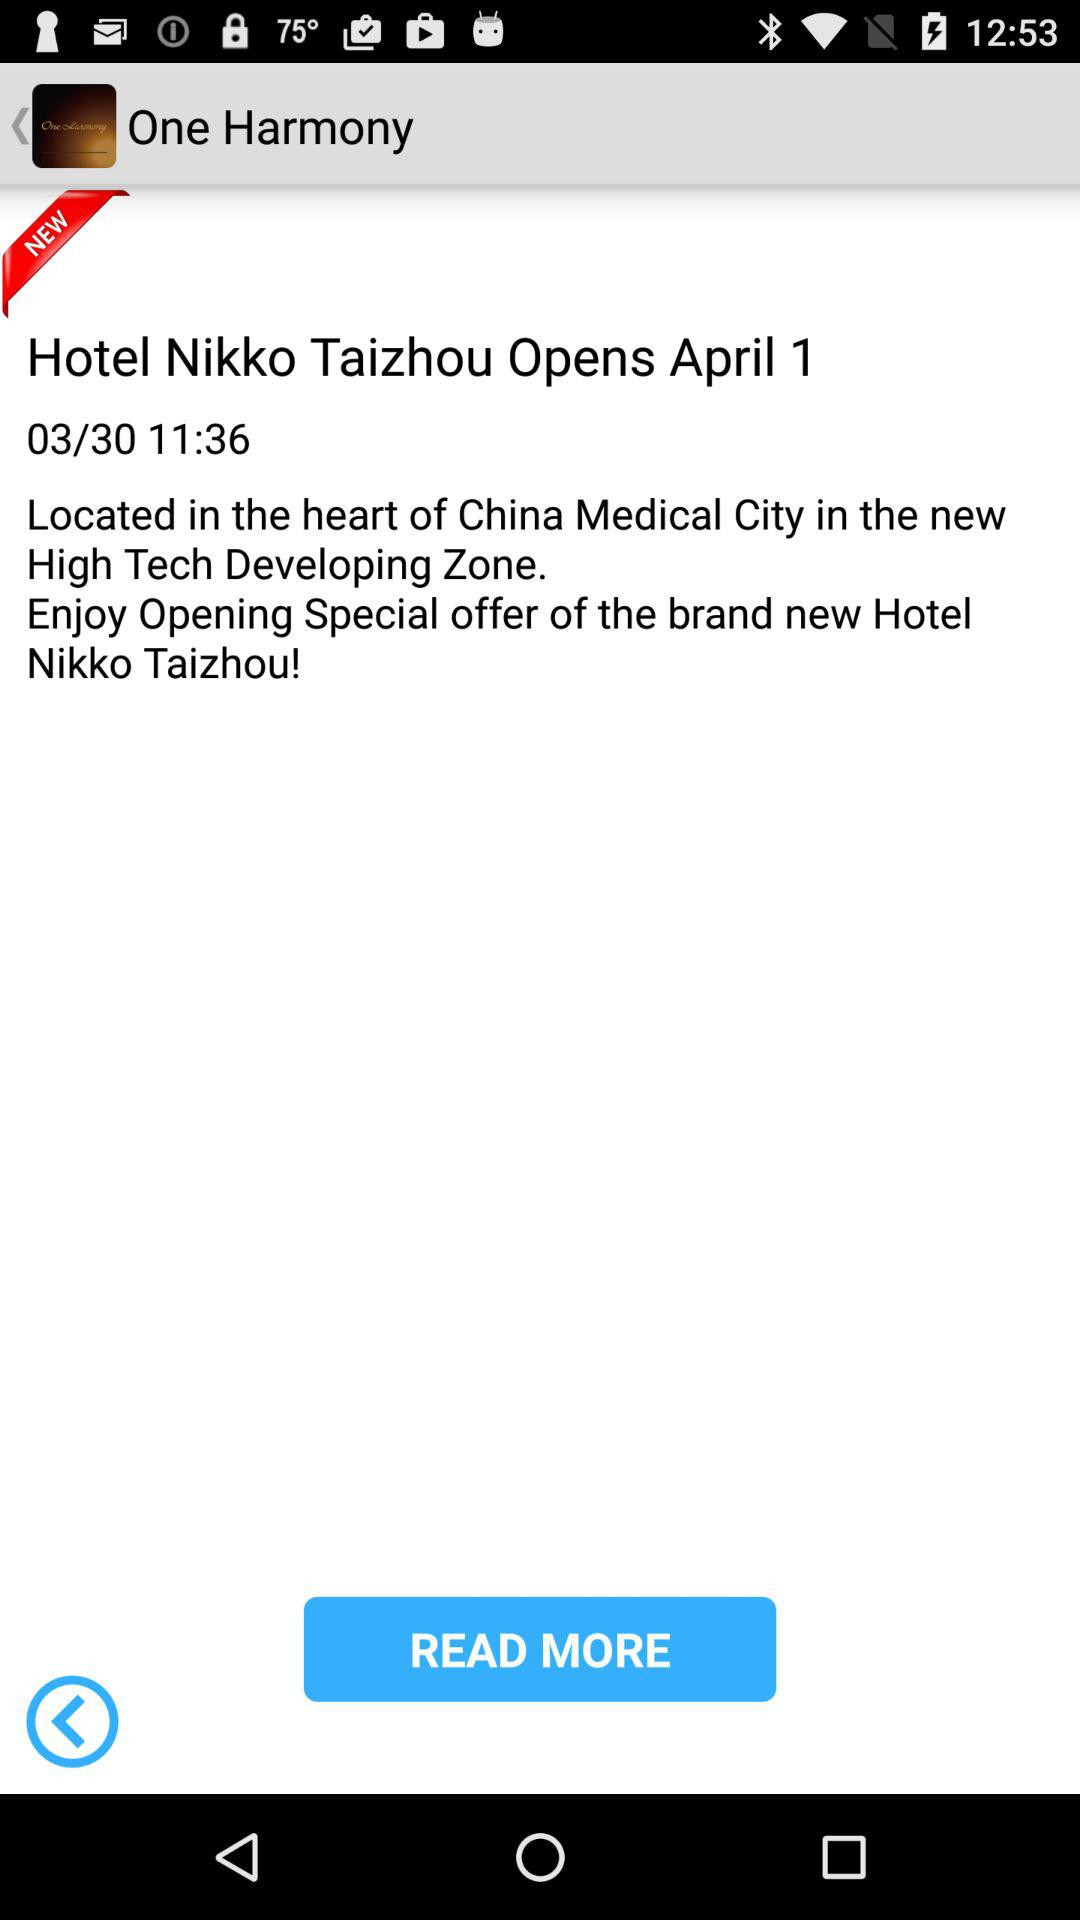What is the hotel name? The hotel name is "Hotel Nikko Taizhou". 